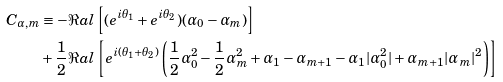Convert formula to latex. <formula><loc_0><loc_0><loc_500><loc_500>C _ { \alpha , m } & \equiv - \Re a l \left [ ( e ^ { i \theta _ { 1 } } + e ^ { i \theta _ { 2 } } ) ( \alpha _ { 0 } - \alpha _ { m } ) \right ] \\ & + \frac { 1 } { 2 } \Re a l \left [ e ^ { i ( \theta _ { 1 } + \theta _ { 2 } ) } \left ( \frac { 1 } { 2 } \alpha _ { 0 } ^ { 2 } - \frac { 1 } { 2 } \alpha _ { m } ^ { 2 } + \alpha _ { 1 } - \alpha _ { m + 1 } - \alpha _ { 1 } | \alpha _ { 0 } ^ { 2 } | + \alpha _ { m + 1 } | \alpha _ { m } | ^ { 2 } \right ) \right ]</formula> 